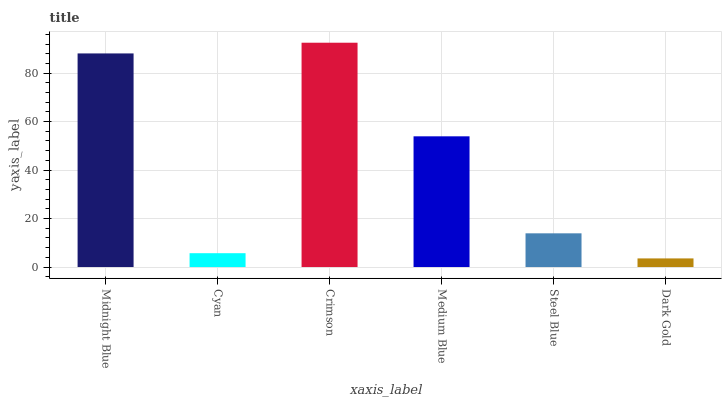Is Dark Gold the minimum?
Answer yes or no. Yes. Is Crimson the maximum?
Answer yes or no. Yes. Is Cyan the minimum?
Answer yes or no. No. Is Cyan the maximum?
Answer yes or no. No. Is Midnight Blue greater than Cyan?
Answer yes or no. Yes. Is Cyan less than Midnight Blue?
Answer yes or no. Yes. Is Cyan greater than Midnight Blue?
Answer yes or no. No. Is Midnight Blue less than Cyan?
Answer yes or no. No. Is Medium Blue the high median?
Answer yes or no. Yes. Is Steel Blue the low median?
Answer yes or no. Yes. Is Dark Gold the high median?
Answer yes or no. No. Is Medium Blue the low median?
Answer yes or no. No. 